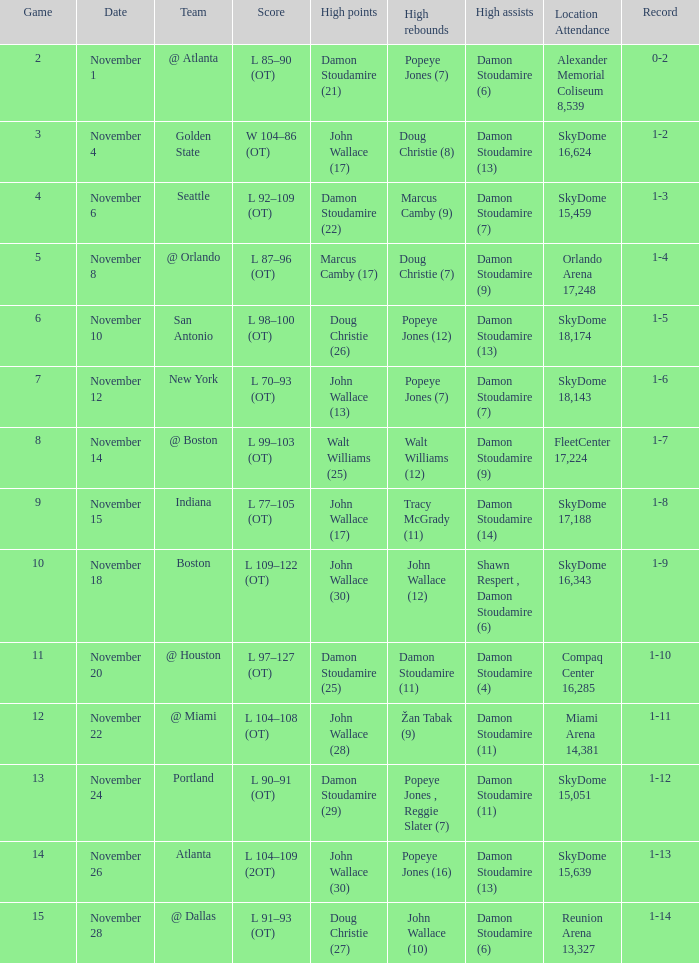What was the tally against san antonio? L 98–100 (OT). 